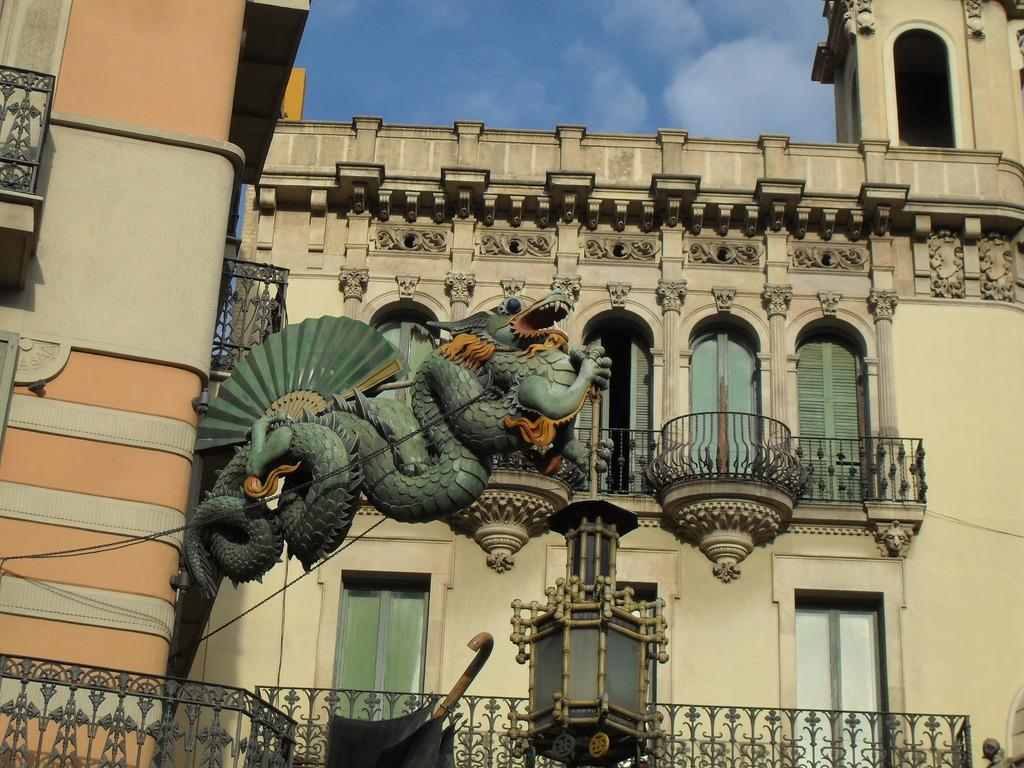What type of structures can be seen in the image? There are buildings in the image. What architectural features are present on the buildings? There are windows, doors, grills, a fence, and pillars in the image. What additional object can be found in the image? There is a sculpture in the image. What is visible in the background of the image? The sky is visible in the background of the image, and there are clouds in the sky. What shape is the square in the image? There is no square present in the image. What type of journey is depicted in the image? There is no journey depicted in the image; it features buildings, architectural features, and a sculpture. 